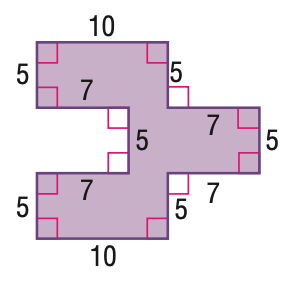Answer the mathemtical geometry problem and directly provide the correct option letter.
Question: Find the area of the figure.
Choices: A: 105 B: 135 C: 150 D: 160 C 